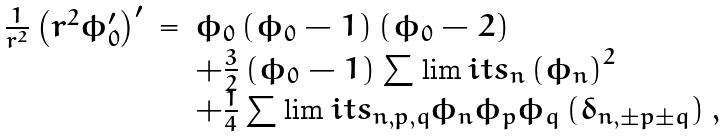<formula> <loc_0><loc_0><loc_500><loc_500>\begin{array} { r c l } \frac { 1 } { r ^ { 2 } } \left ( r ^ { 2 } \phi _ { 0 } ^ { \prime } \right ) ^ { \prime } & = & \phi _ { 0 } \left ( \phi _ { 0 } - 1 \right ) \left ( \phi _ { 0 } - 2 \right ) \\ & & + \frac { 3 } { 2 } \left ( \phi _ { 0 } - 1 \right ) \sum \lim i t s _ { n } \left ( \phi _ { n } \right ) ^ { 2 } \\ & & + \frac { 1 } { 4 } \sum \lim i t s _ { n , p , q } \phi _ { n } \phi _ { p } \phi _ { q } \left ( \delta _ { n , \pm p \pm q } \right ) , \end{array}</formula> 